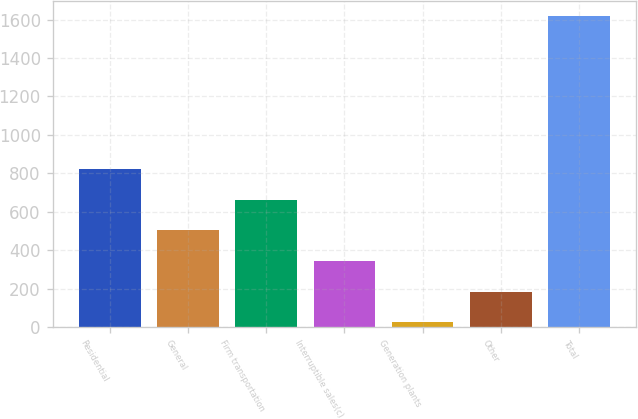Convert chart. <chart><loc_0><loc_0><loc_500><loc_500><bar_chart><fcel>Residential<fcel>General<fcel>Firm transportation<fcel>Interruptible sales(c)<fcel>Generation plants<fcel>Other<fcel>Total<nl><fcel>821<fcel>503<fcel>662<fcel>344<fcel>26<fcel>185<fcel>1616<nl></chart> 